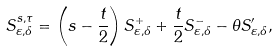<formula> <loc_0><loc_0><loc_500><loc_500>S ^ { s , \tau } _ { \varepsilon , \delta } = \left ( s - \frac { t } { 2 } \right ) S _ { \varepsilon , \delta } ^ { + } + \frac { t } { 2 } S _ { \varepsilon , \delta } ^ { - } - \theta S ^ { \prime } _ { \varepsilon , \delta } ,</formula> 